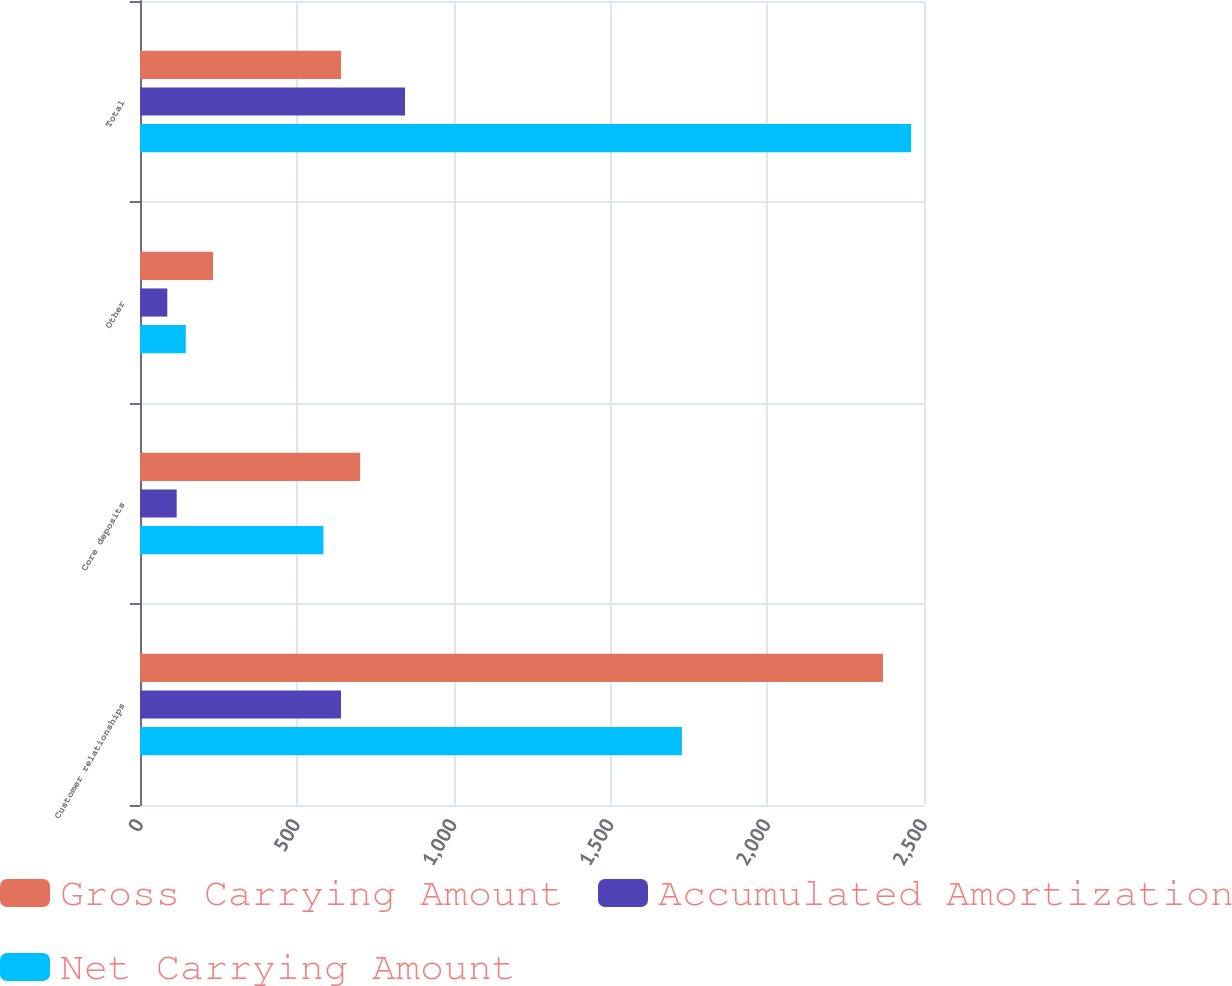<chart> <loc_0><loc_0><loc_500><loc_500><stacked_bar_chart><ecel><fcel>Customer relationships<fcel>Core deposits<fcel>Other<fcel>Total<nl><fcel>Gross Carrying Amount<fcel>2369<fcel>702<fcel>233<fcel>641<nl><fcel>Accumulated Amortization<fcel>641<fcel>117<fcel>87<fcel>845<nl><fcel>Net Carrying Amount<fcel>1728<fcel>585<fcel>146<fcel>2459<nl></chart> 